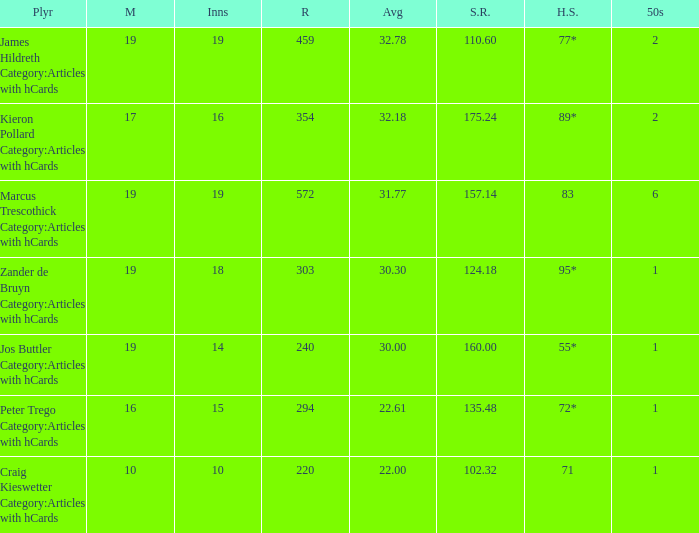What is the strike rate for the player with an average of 32.78? 110.6. 